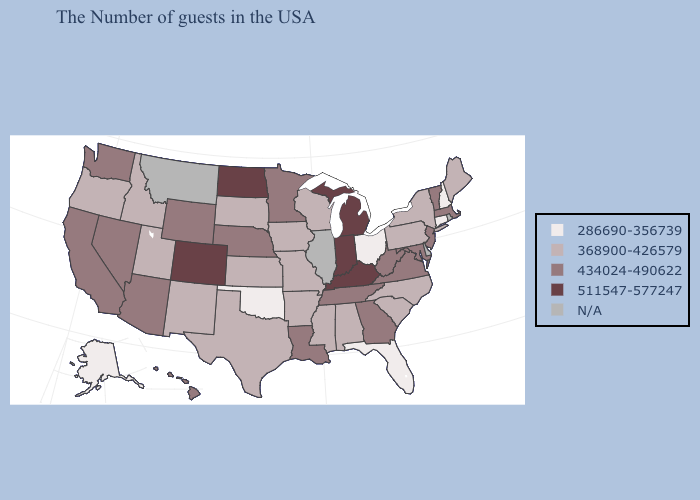What is the value of Illinois?
Answer briefly. N/A. Name the states that have a value in the range 511547-577247?
Concise answer only. Michigan, Kentucky, Indiana, North Dakota, Colorado. Which states hav the highest value in the Northeast?
Answer briefly. Massachusetts, Vermont, New Jersey. Among the states that border Idaho , does Utah have the highest value?
Answer briefly. No. What is the lowest value in states that border Connecticut?
Write a very short answer. 368900-426579. What is the value of Tennessee?
Give a very brief answer. 434024-490622. Does Connecticut have the lowest value in the USA?
Keep it brief. Yes. Does Massachusetts have the highest value in the USA?
Answer briefly. No. Does Arkansas have the highest value in the South?
Short answer required. No. Among the states that border South Dakota , which have the lowest value?
Quick response, please. Iowa. Does New Hampshire have the lowest value in the Northeast?
Answer briefly. Yes. Which states have the lowest value in the USA?
Short answer required. New Hampshire, Connecticut, Ohio, Florida, Oklahoma, Alaska. Does Colorado have the highest value in the West?
Keep it brief. Yes. What is the lowest value in states that border New York?
Write a very short answer. 286690-356739. 